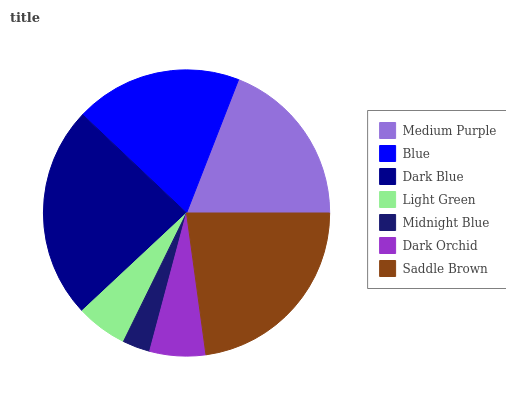Is Midnight Blue the minimum?
Answer yes or no. Yes. Is Dark Blue the maximum?
Answer yes or no. Yes. Is Blue the minimum?
Answer yes or no. No. Is Blue the maximum?
Answer yes or no. No. Is Medium Purple greater than Blue?
Answer yes or no. Yes. Is Blue less than Medium Purple?
Answer yes or no. Yes. Is Blue greater than Medium Purple?
Answer yes or no. No. Is Medium Purple less than Blue?
Answer yes or no. No. Is Blue the high median?
Answer yes or no. Yes. Is Blue the low median?
Answer yes or no. Yes. Is Medium Purple the high median?
Answer yes or no. No. Is Midnight Blue the low median?
Answer yes or no. No. 